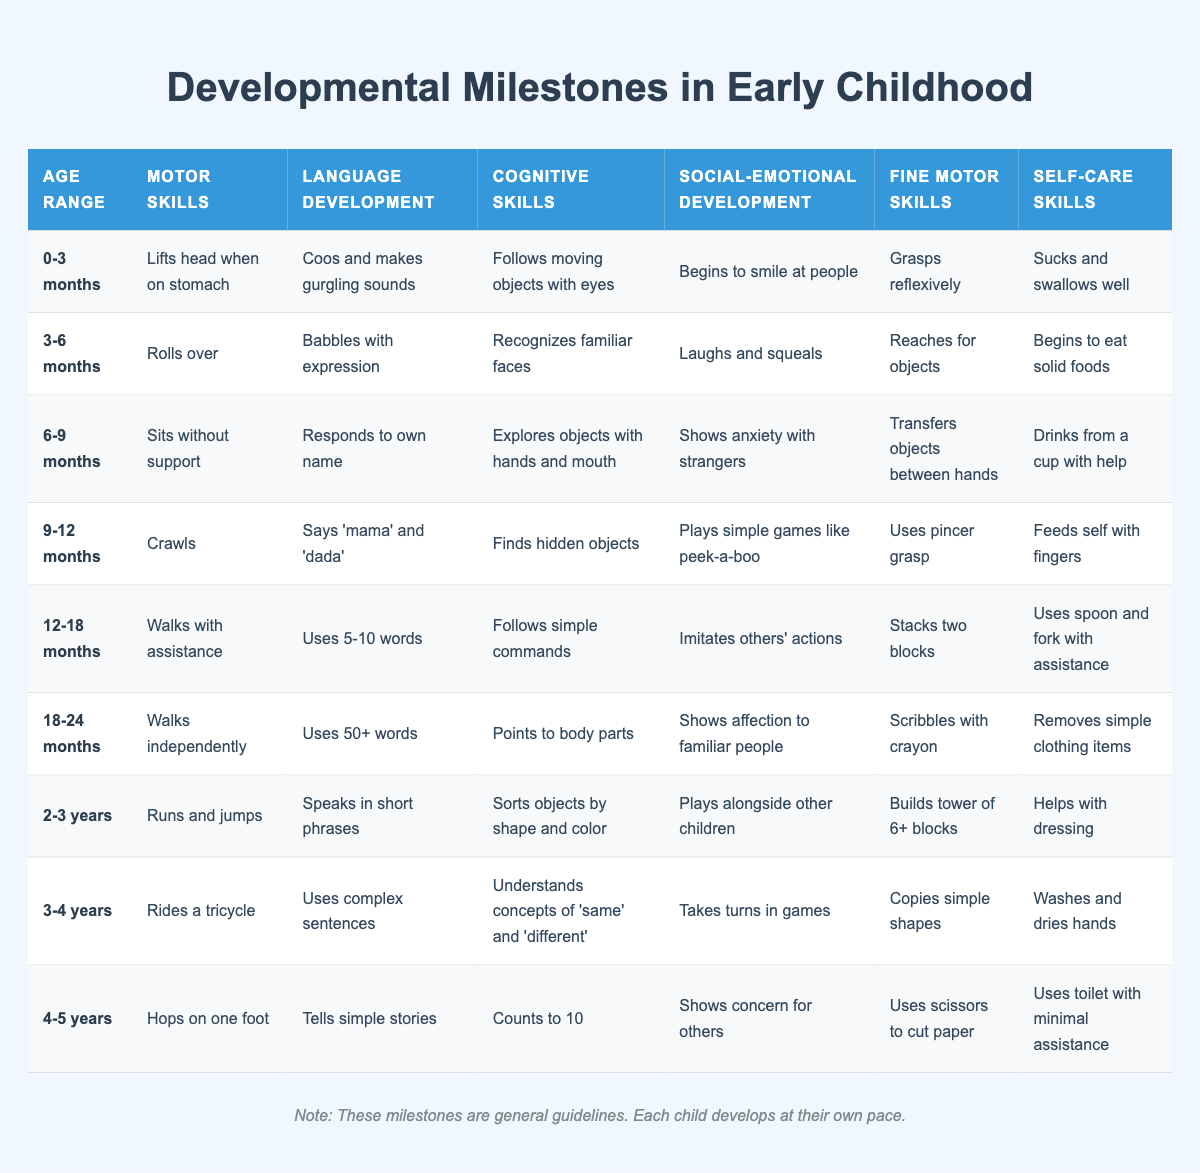What developmental milestone in motor skills can a child typically achieve by 9-12 months? According to the table, a child typically achieves crawling as a motor skill milestone by 9-12 months.
Answer: Crawls At what age range does a child start to walk independently? The table indicates that a child typically starts walking independently between 18-24 months.
Answer: 18-24 months Can a child use a spoon and fork with assistance by 12-18 months? Yes, the table states that during 12-18 months, a child can use a spoon and fork with assistance.
Answer: Yes What is the cognitive skill milestone for children aged 3-4 years? The table shows that children aged 3-4 years understand concepts of 'same' and 'different' as their cognitive skill milestone.
Answer: Understands concepts of 'same' and 'different' What is the average age range for achieving the language development skills of using complex sentences? From the table, using complex sentences typically occurs at 3-4 years, which is a single age range, so the average is simply that age range.
Answer: 3-4 years How many self-care skills are children expected to demonstrate by the age of 2-3 years? Referring to the table, by the age of 2-3 years, children are expected to demonstrate 6 self-care skills, which are helping with dressing, washing and drying hands, etc.
Answer: 6 Is it true that children aged 0-3 months can mainly follow moving objects with their eyes? Yes, according to the table, following moving objects with their eyes is a milestone for children aged 0-3 months.
Answer: Yes What are the fine motor skills milestones for children aged 4-5 years? The table indicates that children aged 4-5 years can use scissors to cut paper and hop on one foot as fine motor skills milestones.
Answer: Uses scissors to cut paper Which social-emotional milestone comes before a child begins to smile at people? The milestone of beginning to smile at people occurs at the age of 0-3 months, thus there isn't a previous milestone listed in this context; it is the earliest listed.
Answer: N/A 